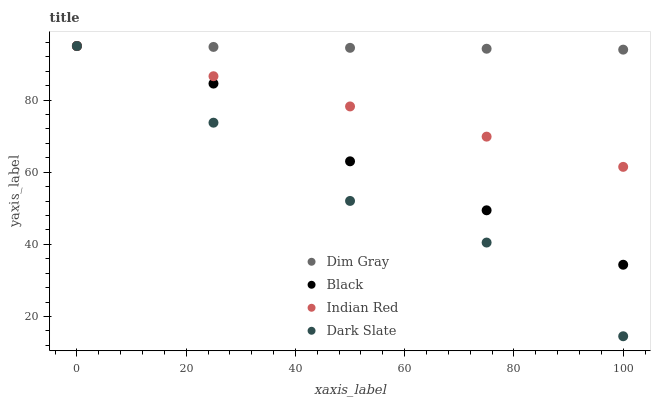Does Dark Slate have the minimum area under the curve?
Answer yes or no. Yes. Does Dim Gray have the maximum area under the curve?
Answer yes or no. Yes. Does Black have the minimum area under the curve?
Answer yes or no. No. Does Black have the maximum area under the curve?
Answer yes or no. No. Is Indian Red the smoothest?
Answer yes or no. Yes. Is Dark Slate the roughest?
Answer yes or no. Yes. Is Dim Gray the smoothest?
Answer yes or no. No. Is Dim Gray the roughest?
Answer yes or no. No. Does Dark Slate have the lowest value?
Answer yes or no. Yes. Does Black have the lowest value?
Answer yes or no. No. Does Indian Red have the highest value?
Answer yes or no. Yes. Does Dim Gray intersect Indian Red?
Answer yes or no. Yes. Is Dim Gray less than Indian Red?
Answer yes or no. No. Is Dim Gray greater than Indian Red?
Answer yes or no. No. 